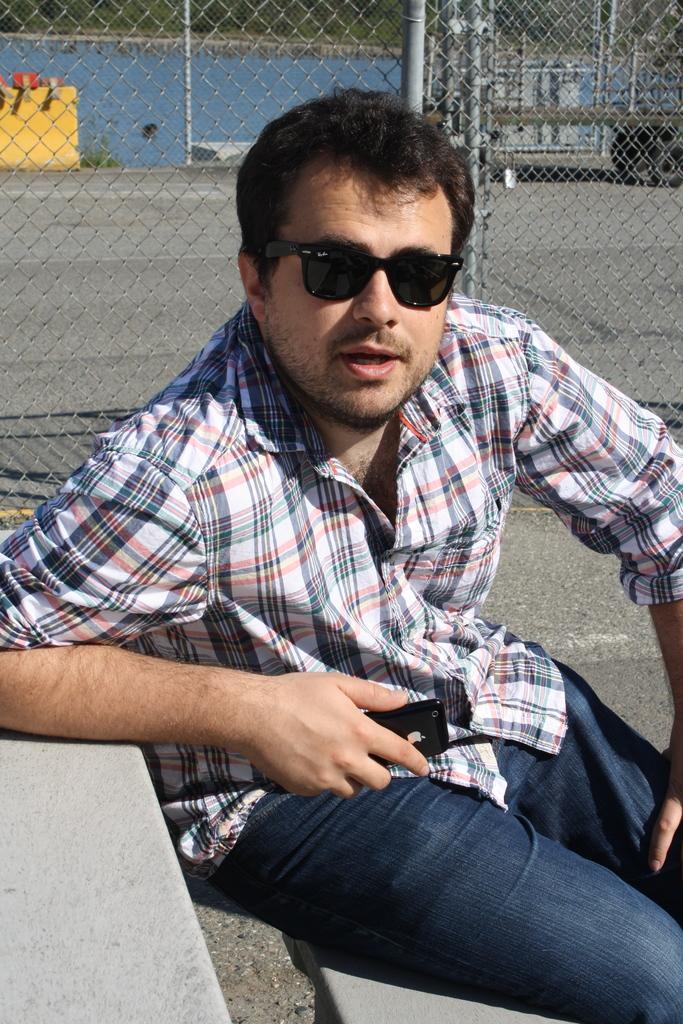Describe this image in one or two sentences. In the middle of this image, there is a person in a shirt, sitting on a bench, holding a mobile, keeping his elbow on a table and speaking. In the background, there is a trolley on the road, there is water and there are trees. 